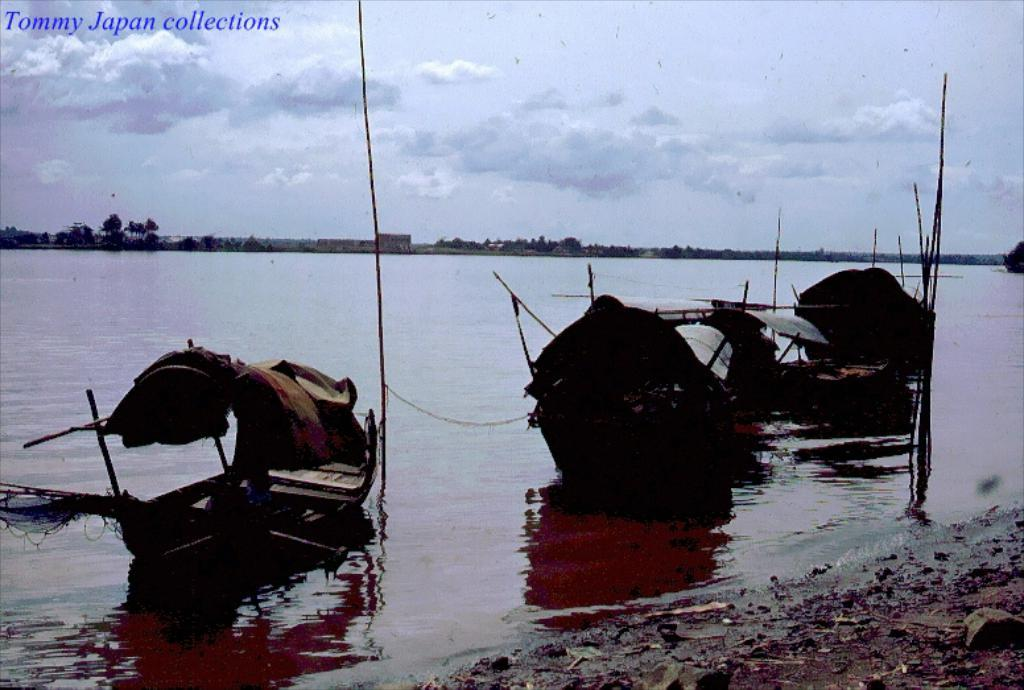What is in the water in the image? There are boats in the water in the image. What type of vegetation can be seen in the image? There are trees visible in the image. What is visible in the sky in the image? There are clouds in the sky in the image. What is written or displayed at the top of the image? There is text at the top of the image. Can you tell me how many lamps are hanging from the trees in the image? There are no lamps present in the image; it features boats in the water, trees, clouds, and text at the top. What type of memory is being used by the trees in the image? Trees do not have memories, so this question cannot be answered. 